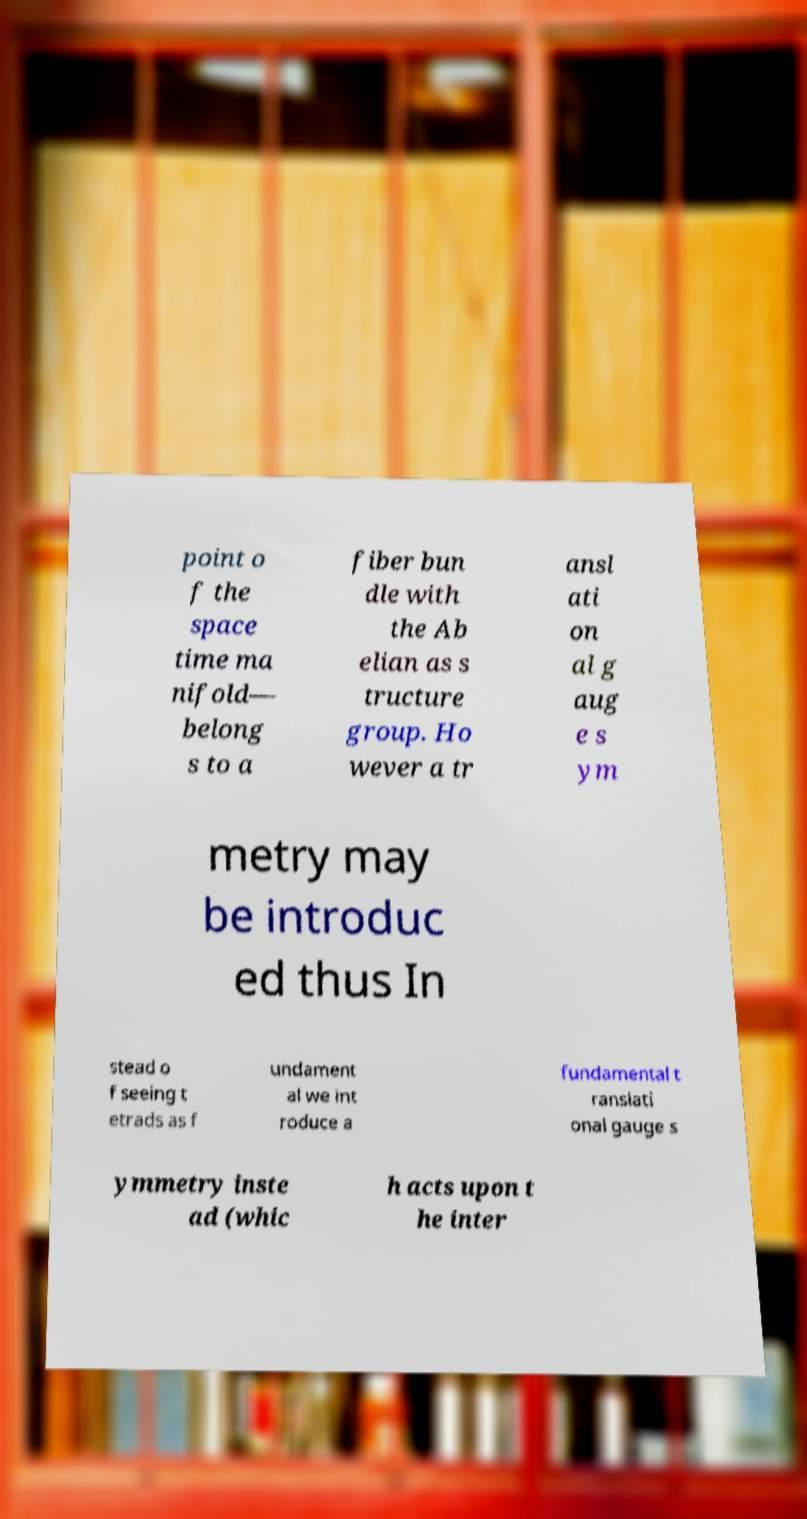What messages or text are displayed in this image? I need them in a readable, typed format. point o f the space time ma nifold— belong s to a fiber bun dle with the Ab elian as s tructure group. Ho wever a tr ansl ati on al g aug e s ym metry may be introduc ed thus In stead o f seeing t etrads as f undament al we int roduce a fundamental t ranslati onal gauge s ymmetry inste ad (whic h acts upon t he inter 